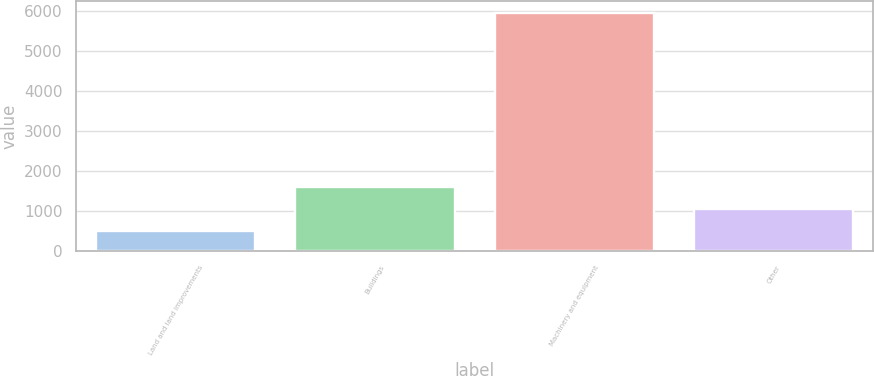<chart> <loc_0><loc_0><loc_500><loc_500><bar_chart><fcel>Land and land improvements<fcel>Buildings<fcel>Machinery and equipment<fcel>Other<nl><fcel>504<fcel>1593.6<fcel>5952<fcel>1048.8<nl></chart> 